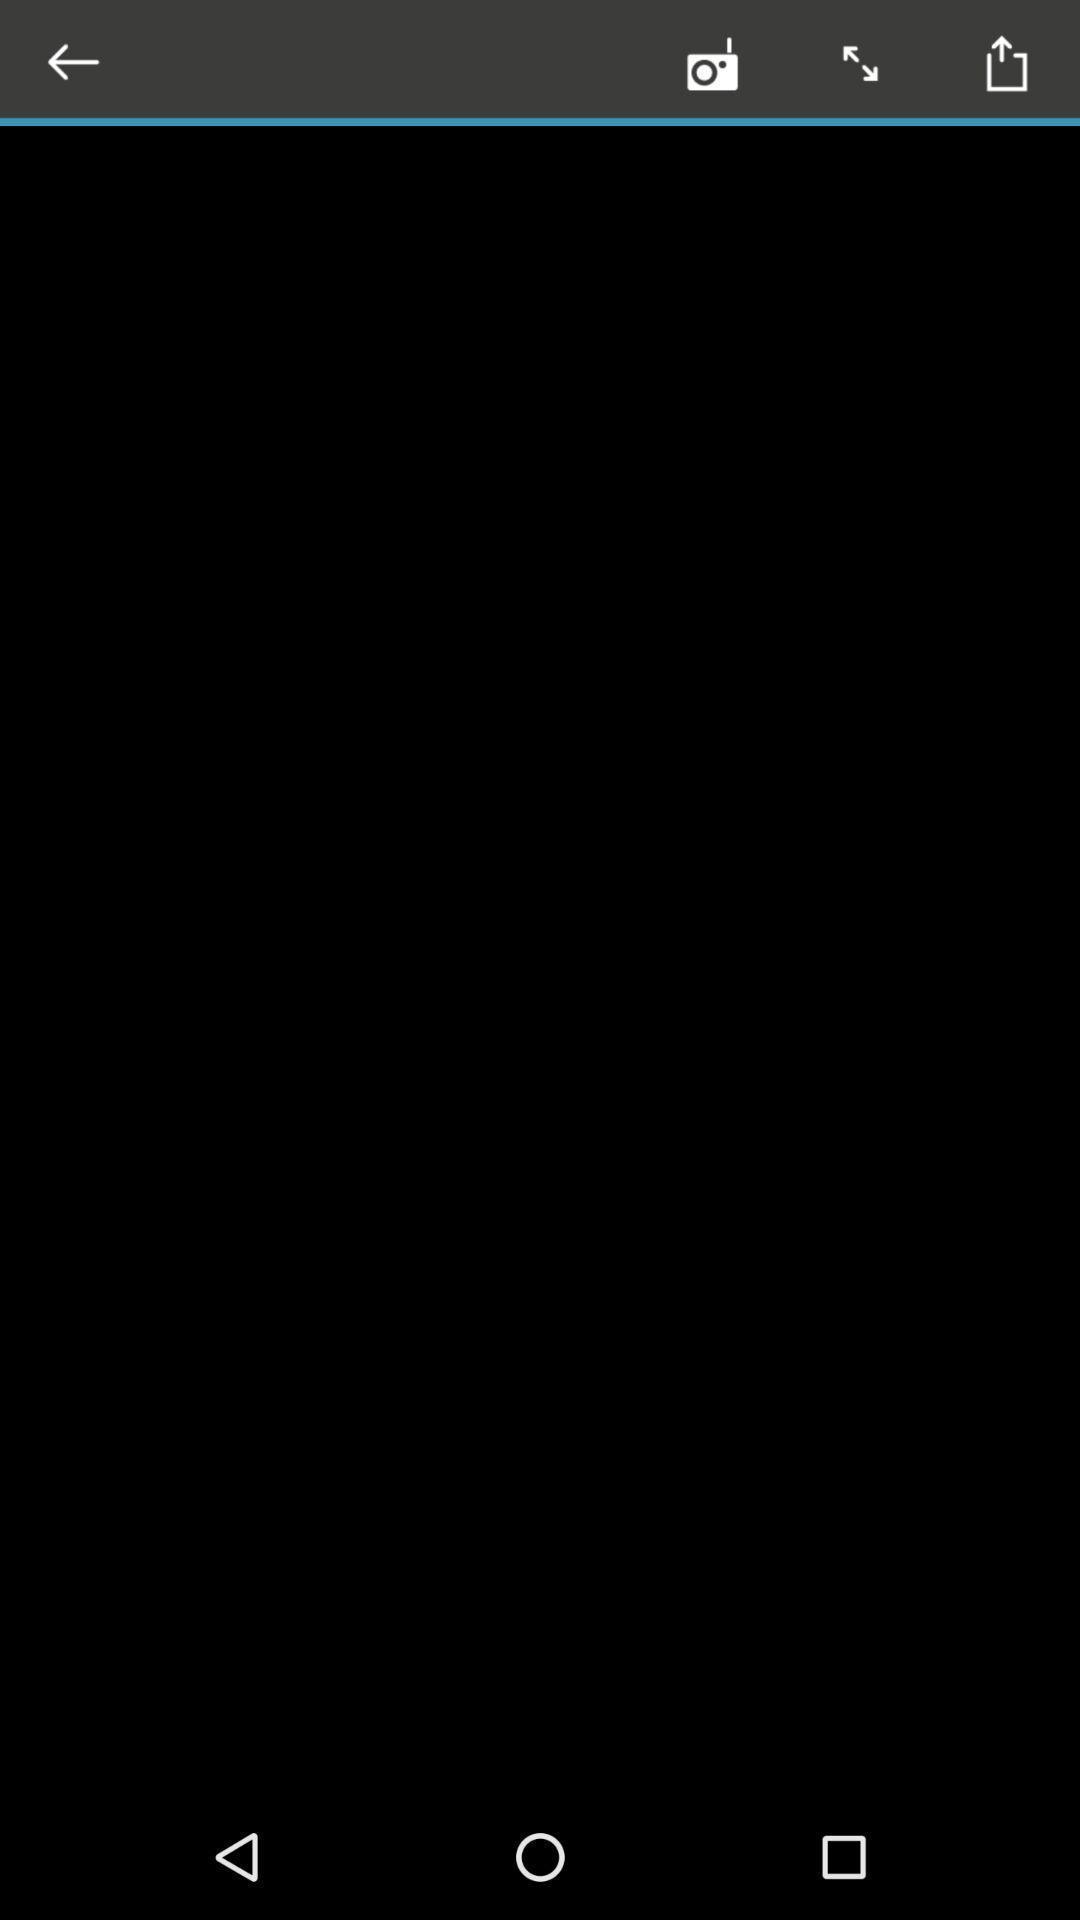Provide a textual representation of this image. Screen showing the blank page. 